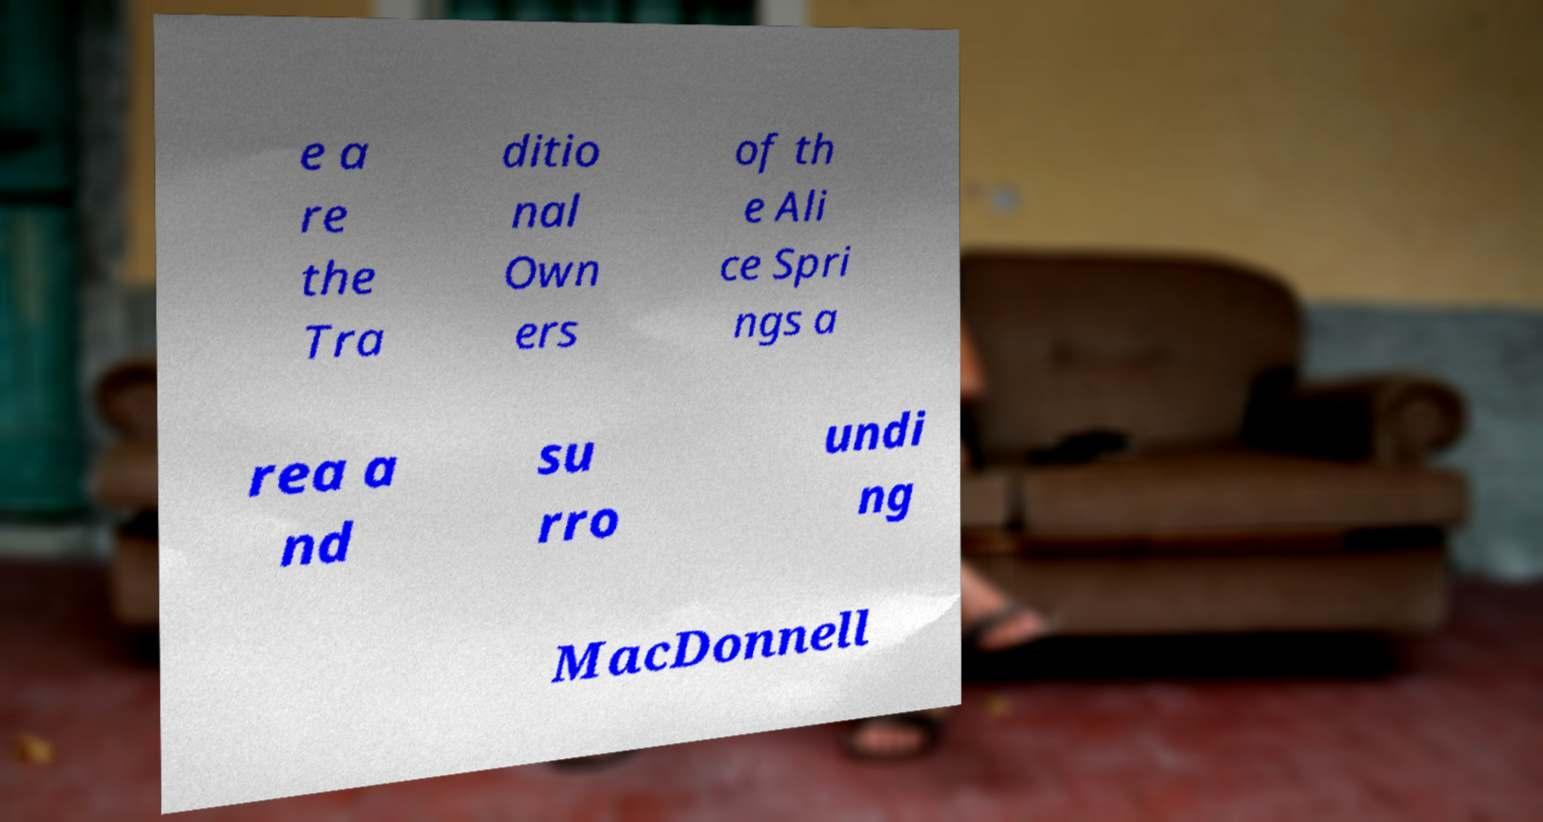For documentation purposes, I need the text within this image transcribed. Could you provide that? e a re the Tra ditio nal Own ers of th e Ali ce Spri ngs a rea a nd su rro undi ng MacDonnell 